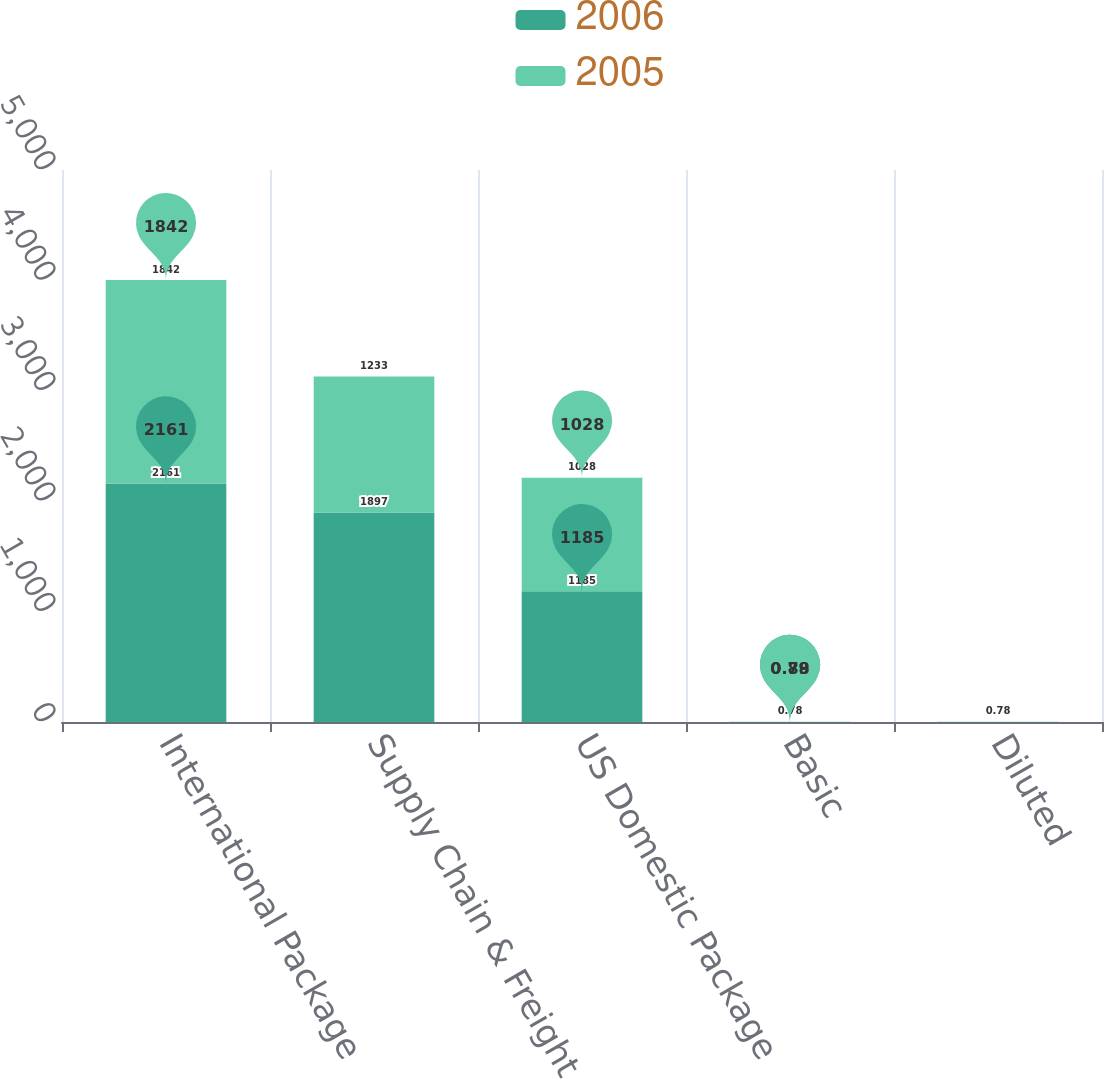<chart> <loc_0><loc_0><loc_500><loc_500><stacked_bar_chart><ecel><fcel>International Package<fcel>Supply Chain & Freight<fcel>US Domestic Package<fcel>Basic<fcel>Diluted<nl><fcel>2006<fcel>2161<fcel>1897<fcel>1185<fcel>0.89<fcel>0.89<nl><fcel>2005<fcel>1842<fcel>1233<fcel>1028<fcel>0.78<fcel>0.78<nl></chart> 